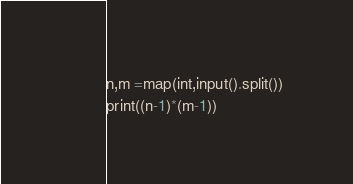<code> <loc_0><loc_0><loc_500><loc_500><_Python_>n,m =map(int,input().split())
print((n-1)*(m-1))</code> 